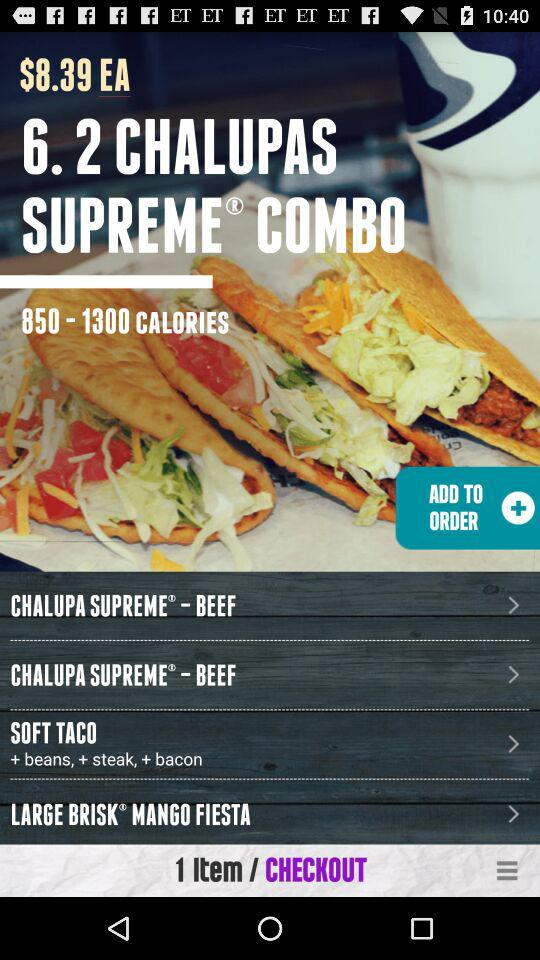What is the price? The price is $8.39 EA. 